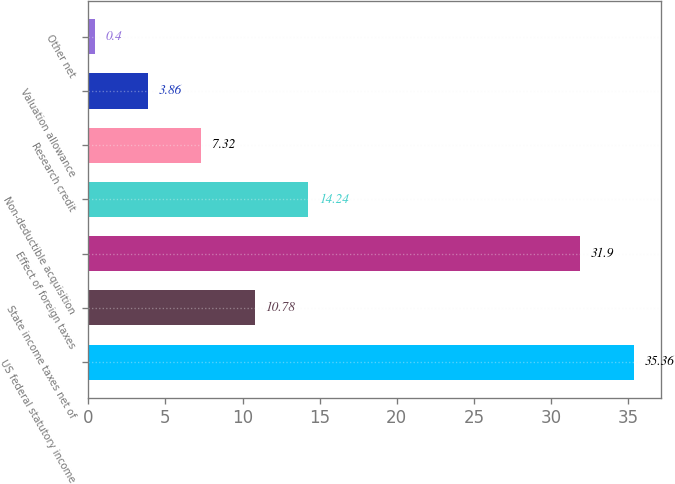Convert chart. <chart><loc_0><loc_0><loc_500><loc_500><bar_chart><fcel>US federal statutory income<fcel>State income taxes net of<fcel>Effect of foreign taxes<fcel>Non-deductible acquisition<fcel>Research credit<fcel>Valuation allowance<fcel>Other net<nl><fcel>35.36<fcel>10.78<fcel>31.9<fcel>14.24<fcel>7.32<fcel>3.86<fcel>0.4<nl></chart> 